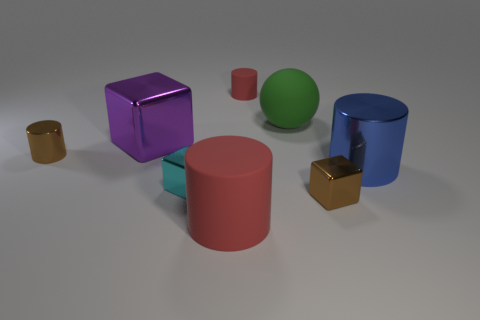How are the objects arranged in the space? The objects are spaced out across a flat, neutral surface. Starting from the left, the small gold cylinder is followed by a pink cylinder of medium size. A purple cube sits prominently in the middle, slightly behind it is a smaller gold cube and a green sphere side by side. Finally, on the far right, there's a large blue cylinder. 